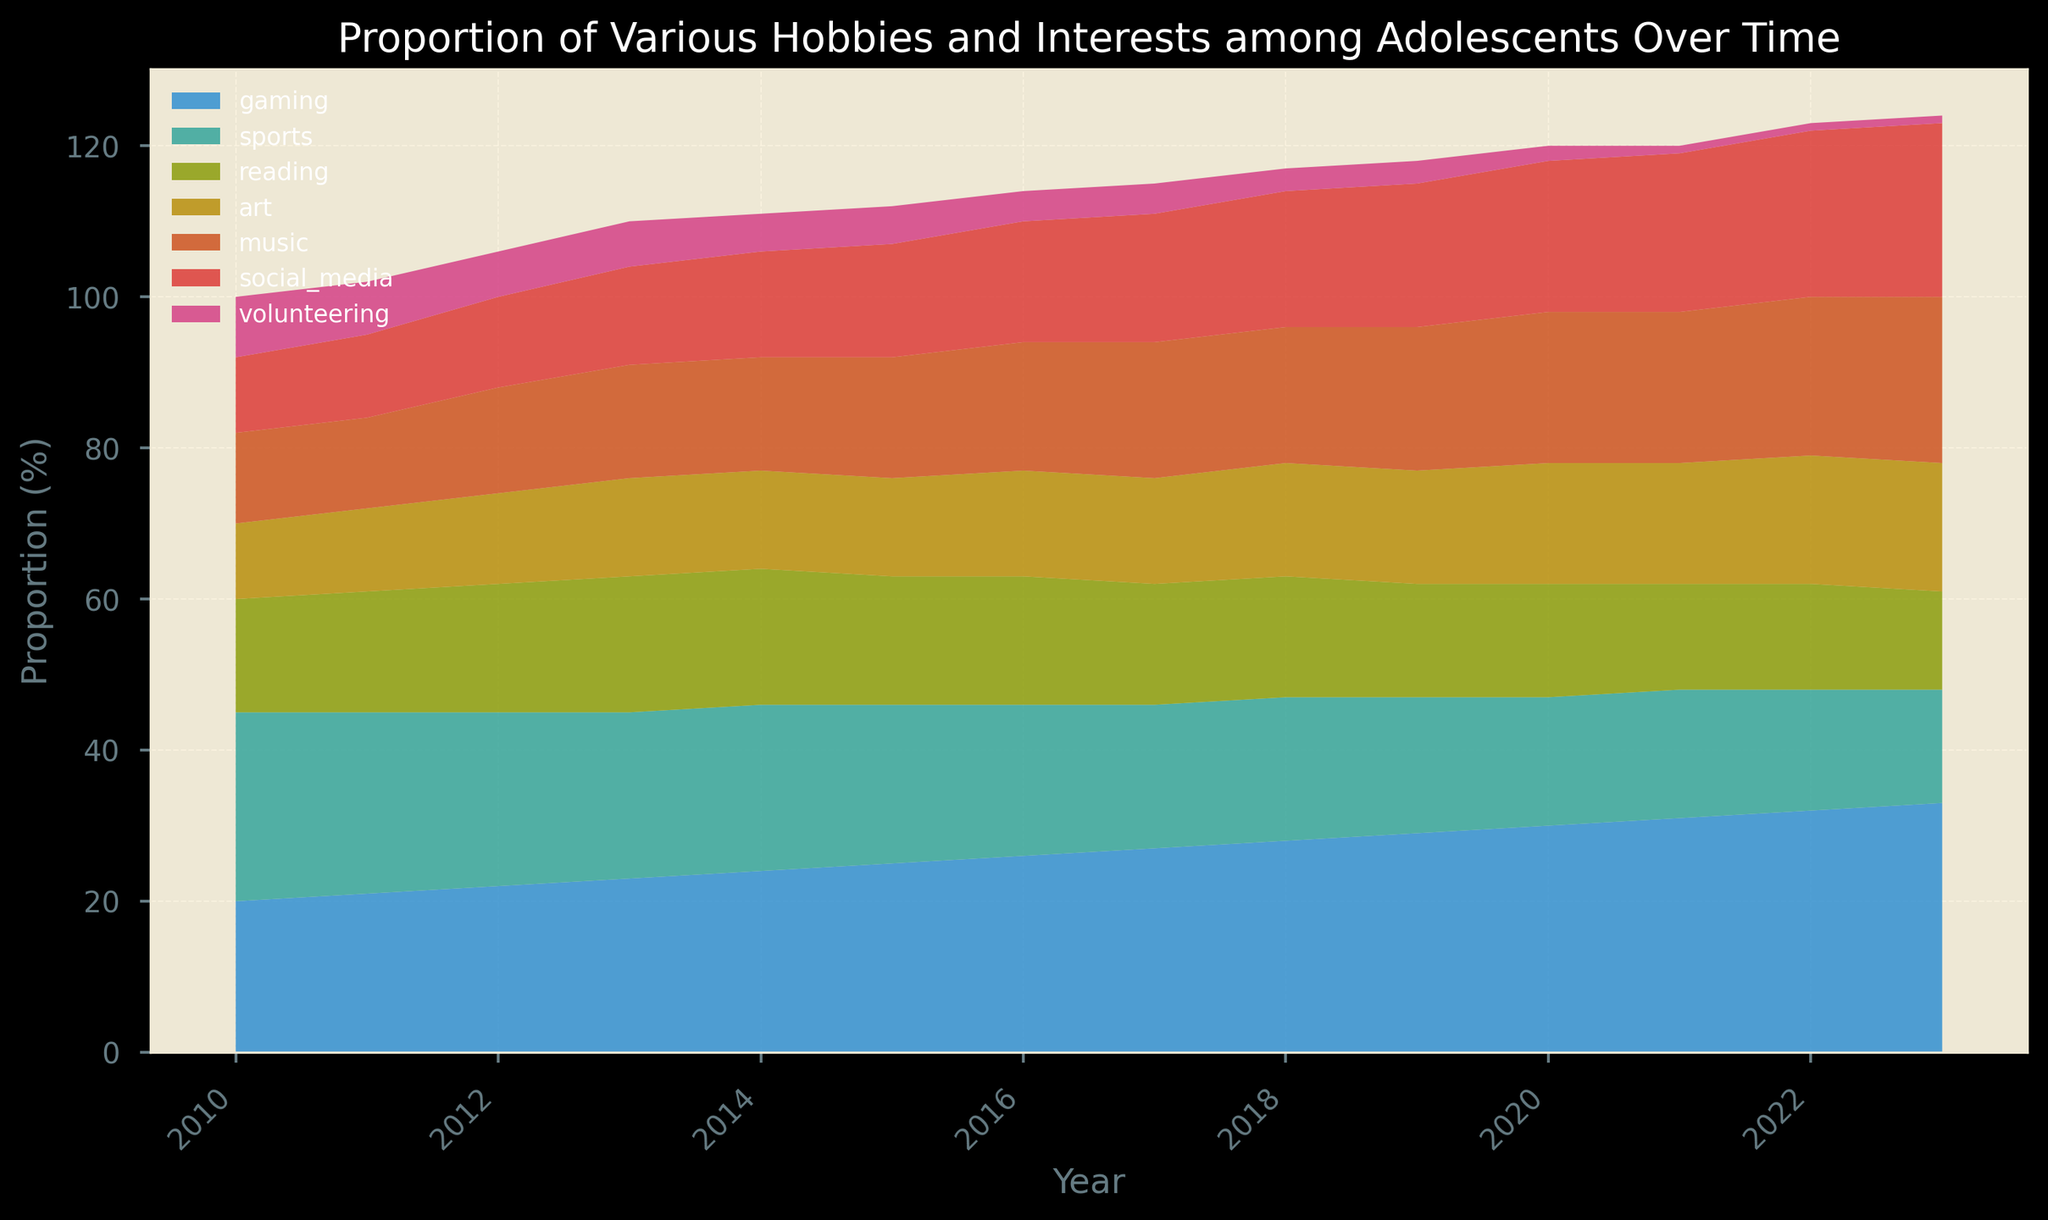What's the trend in the proportion of adolescents participating in gaming over the years? The green area representing gaming continuously increases from 2010 to 2023. Starting at 20% in 2010 and reaching 33% in 2023, it shows a consistent upward trend.
Answer: Increasing Which hobby had the steepest decline from 2010 to 2023? By observing the slopes, social media (teal) had the steepest decline, dropping from 10% in 2010 to 1% in 2023.
Answer: Social Media What is the difference between the proportion of adolescents involved in sports in 2010 and in 2023? In 2010, the proportion for sports (orange area) was at 25%. By 2023, it decreased to 15%. The difference is 25% - 15% = 10%.
Answer: 10% How did the proportion of adolescents interested in music change from 2010 to 2023? The purple area representing music shows a steady increase from 12% in 2010, reaching 22% in 2023, showing a continuous upward trend.
Answer: Increasing Between which years did volunteering experience its largest proportional drop? Volunteering (grey area) dropped from 8% in 2010 to 1% in 2023. The sharpest decline occurred between 2016 and 2017, from 4% to 3%.
Answer: 2016-2017 Which hobbies overtook reading in popularity by 2023 compared to their 2010 levels? Comparing the areas: Gaming, Music, and Social Media overtook reading (which remained relatively stable) in popularity. Reading started and ended around the same proportion.
Answer: Gaming, Music, Social Media In which year did the proportion for art surpass that of reading? By visually tracing the red and light blue areas, art surpassed reading in 2020 (both at 16%), then continued to rise above reading from 2021 onward.
Answer: 2020 Compare the combined proportions of gaming and music in 2013 and 2023. Have they increased or decreased? In 2013: Gaming (23%) + Music (15%) = 38%. In 2023: Gaming (33%) + Music (22%) = 55%. This indicates an overall increase.
Answer: Increased What is the sum of proportions for gaming, sports, and reading in 2015? In 2015, the proportions are: Gaming (25%), Sports (21%), Reading (17%). Summing these yields 25% + 21% + 17% = 63%.
Answer: 63% Which hobby showed the least change in proportion over the years, and what was the approximate change? Reading (light blue area) remained relatively stable, starting at 15% in 2010 and ending at 13% in 2023. The change was approximately 2%.
Answer: Reading, 2% 